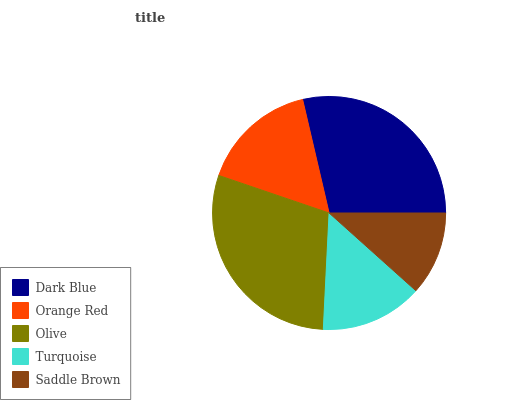Is Saddle Brown the minimum?
Answer yes or no. Yes. Is Olive the maximum?
Answer yes or no. Yes. Is Orange Red the minimum?
Answer yes or no. No. Is Orange Red the maximum?
Answer yes or no. No. Is Dark Blue greater than Orange Red?
Answer yes or no. Yes. Is Orange Red less than Dark Blue?
Answer yes or no. Yes. Is Orange Red greater than Dark Blue?
Answer yes or no. No. Is Dark Blue less than Orange Red?
Answer yes or no. No. Is Orange Red the high median?
Answer yes or no. Yes. Is Orange Red the low median?
Answer yes or no. Yes. Is Saddle Brown the high median?
Answer yes or no. No. Is Olive the low median?
Answer yes or no. No. 